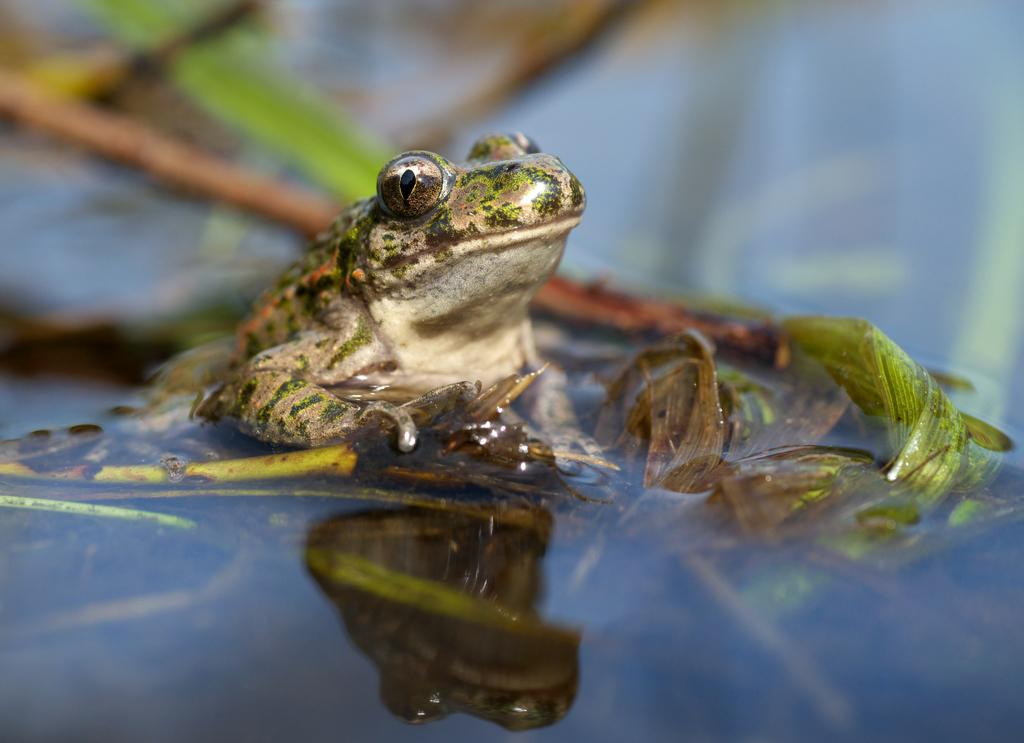What animal is in the water in the image? There is a frog in the water in the image. What other living organism can be seen in the image? There is a plant in the image. Can you describe the background of the image? The background of the image is blurred. What type of muscle is being exercised by the frog in the image? There is no indication in the image that the frog is exercising any muscles, as it is simply sitting in the water. 